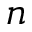<formula> <loc_0><loc_0><loc_500><loc_500>n</formula> 